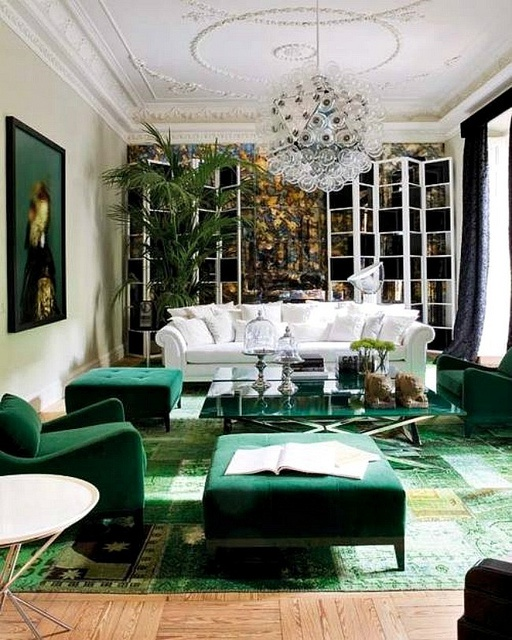Describe the objects in this image and their specific colors. I can see potted plant in lightgray, black, darkgreen, and gray tones, couch in lightgray, darkgray, black, and gray tones, couch in lightgray, black, darkgreen, and teal tones, chair in lightgray, black, darkgreen, and teal tones, and dining table in lightgray, white, tan, black, and gray tones in this image. 